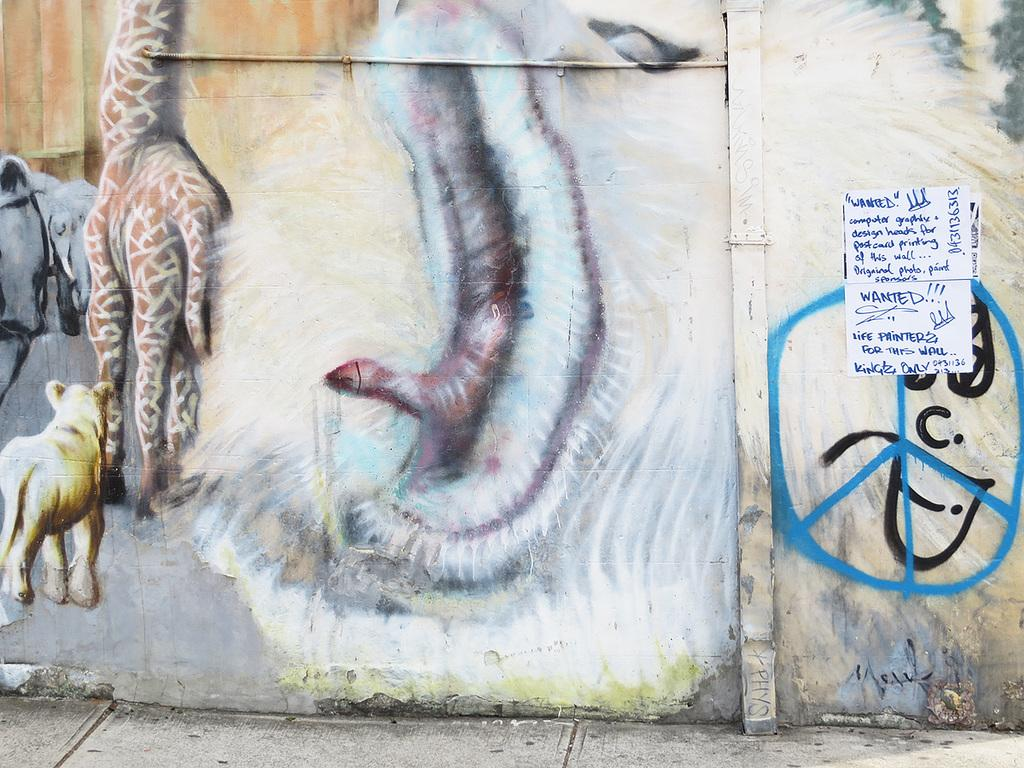What type of artwork is depicted on the wall in the image? There is an art of animals painted on the wall in the image. What other object can be seen in the image besides the artwork? There is a poster in the image. What is written on the poster? The poster has text written on it. Where is the throne located in the image? There is no throne present in the image. What type of shoe is depicted on the poster? There is no shoe depicted on the poster; it has text written on it. 